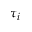<formula> <loc_0><loc_0><loc_500><loc_500>\tau _ { i }</formula> 